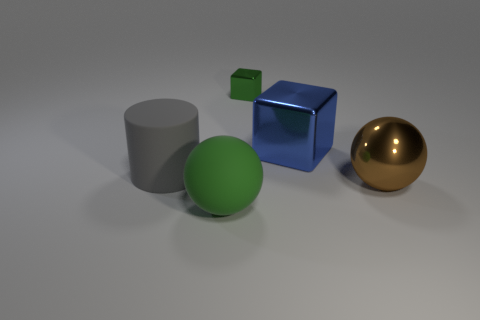Is there any other thing that is made of the same material as the large green thing?
Your answer should be very brief. Yes. How many brown shiny things have the same shape as the large blue shiny thing?
Your answer should be very brief. 0. There is a green thing that is the same material as the blue block; what size is it?
Your answer should be very brief. Small. Are there any large green matte spheres behind the big rubber thing in front of the big shiny object in front of the big block?
Offer a terse response. No. Does the sphere behind the green matte sphere have the same size as the large green matte sphere?
Offer a terse response. Yes. How many other things have the same size as the green rubber object?
Offer a very short reply. 3. There is a ball that is the same color as the tiny metal cube; what size is it?
Your response must be concise. Large. Do the large metal block and the small metal cube have the same color?
Offer a very short reply. No. What is the shape of the brown metal object?
Give a very brief answer. Sphere. Is there a shiny object of the same color as the small shiny cube?
Keep it short and to the point. No. 